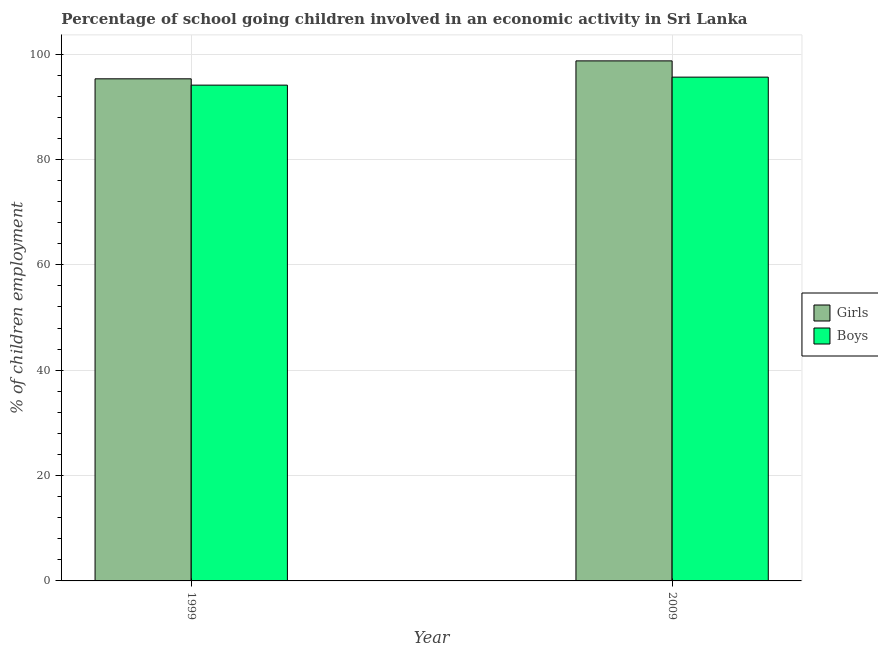Are the number of bars per tick equal to the number of legend labels?
Your answer should be very brief. Yes. Are the number of bars on each tick of the X-axis equal?
Give a very brief answer. Yes. How many bars are there on the 1st tick from the right?
Your response must be concise. 2. In how many cases, is the number of bars for a given year not equal to the number of legend labels?
Ensure brevity in your answer.  0. What is the percentage of school going girls in 1999?
Your answer should be compact. 95.3. Across all years, what is the maximum percentage of school going girls?
Your answer should be very brief. 98.71. Across all years, what is the minimum percentage of school going boys?
Offer a very short reply. 94.1. In which year was the percentage of school going girls maximum?
Offer a very short reply. 2009. In which year was the percentage of school going boys minimum?
Give a very brief answer. 1999. What is the total percentage of school going girls in the graph?
Make the answer very short. 194.01. What is the difference between the percentage of school going boys in 1999 and that in 2009?
Offer a terse response. -1.52. What is the difference between the percentage of school going girls in 2009 and the percentage of school going boys in 1999?
Your answer should be compact. 3.41. What is the average percentage of school going girls per year?
Provide a short and direct response. 97. In the year 2009, what is the difference between the percentage of school going girls and percentage of school going boys?
Your answer should be compact. 0. In how many years, is the percentage of school going girls greater than 28 %?
Offer a terse response. 2. What is the ratio of the percentage of school going boys in 1999 to that in 2009?
Give a very brief answer. 0.98. Is the percentage of school going boys in 1999 less than that in 2009?
Your answer should be very brief. Yes. What does the 1st bar from the left in 2009 represents?
Your response must be concise. Girls. What does the 1st bar from the right in 1999 represents?
Your answer should be very brief. Boys. Are all the bars in the graph horizontal?
Your answer should be very brief. No. What is the difference between two consecutive major ticks on the Y-axis?
Ensure brevity in your answer.  20. Does the graph contain any zero values?
Keep it short and to the point. No. Where does the legend appear in the graph?
Your answer should be very brief. Center right. What is the title of the graph?
Ensure brevity in your answer.  Percentage of school going children involved in an economic activity in Sri Lanka. What is the label or title of the X-axis?
Give a very brief answer. Year. What is the label or title of the Y-axis?
Provide a succinct answer. % of children employment. What is the % of children employment in Girls in 1999?
Your answer should be compact. 95.3. What is the % of children employment of Boys in 1999?
Your answer should be compact. 94.1. What is the % of children employment of Girls in 2009?
Ensure brevity in your answer.  98.71. What is the % of children employment of Boys in 2009?
Give a very brief answer. 95.62. Across all years, what is the maximum % of children employment in Girls?
Offer a very short reply. 98.71. Across all years, what is the maximum % of children employment in Boys?
Your response must be concise. 95.62. Across all years, what is the minimum % of children employment in Girls?
Give a very brief answer. 95.3. Across all years, what is the minimum % of children employment in Boys?
Keep it short and to the point. 94.1. What is the total % of children employment in Girls in the graph?
Give a very brief answer. 194. What is the total % of children employment in Boys in the graph?
Provide a short and direct response. 189.72. What is the difference between the % of children employment in Girls in 1999 and that in 2009?
Your response must be concise. -3.4. What is the difference between the % of children employment in Boys in 1999 and that in 2009?
Provide a short and direct response. -1.52. What is the difference between the % of children employment of Girls in 1999 and the % of children employment of Boys in 2009?
Offer a very short reply. -0.32. What is the average % of children employment of Girls per year?
Your response must be concise. 97. What is the average % of children employment in Boys per year?
Provide a short and direct response. 94.86. In the year 2009, what is the difference between the % of children employment in Girls and % of children employment in Boys?
Your response must be concise. 3.08. What is the ratio of the % of children employment of Girls in 1999 to that in 2009?
Provide a succinct answer. 0.97. What is the ratio of the % of children employment in Boys in 1999 to that in 2009?
Your response must be concise. 0.98. What is the difference between the highest and the second highest % of children employment in Girls?
Offer a very short reply. 3.4. What is the difference between the highest and the second highest % of children employment in Boys?
Your response must be concise. 1.52. What is the difference between the highest and the lowest % of children employment in Girls?
Ensure brevity in your answer.  3.4. What is the difference between the highest and the lowest % of children employment of Boys?
Offer a terse response. 1.52. 